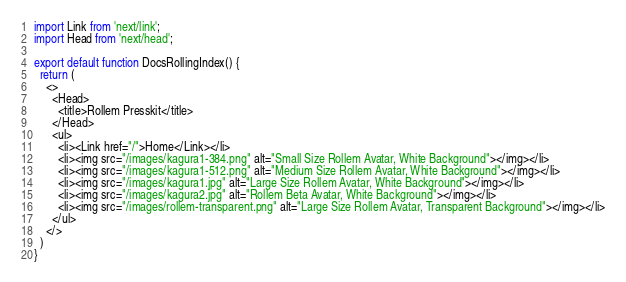<code> <loc_0><loc_0><loc_500><loc_500><_TypeScript_>import Link from 'next/link';
import Head from 'next/head';

export default function DocsRollingIndex() {
  return (
    <>
      <Head>
        <title>Rollem Presskit</title>
      </Head>
      <ul>
        <li><Link href="/">Home</Link></li>
        <li><img src="/images/kagura1-384.png" alt="Small Size Rollem Avatar, White Background"></img></li>
        <li><img src="/images/kagura1-512.png" alt="Medium Size Rollem Avatar, White Background"></img></li>
        <li><img src="/images/kagura1.jpg" alt="Large Size Rollem Avatar, White Background"></img></li>
        <li><img src="/images/kagura2.jpg" alt="Rollem Beta Avatar, White Background"></img></li>
        <li><img src="/images/rollem-transparent.png" alt="Large Size Rollem Avatar, Transparent Background"></img></li>
      </ul>
    </>
  )
}
</code> 